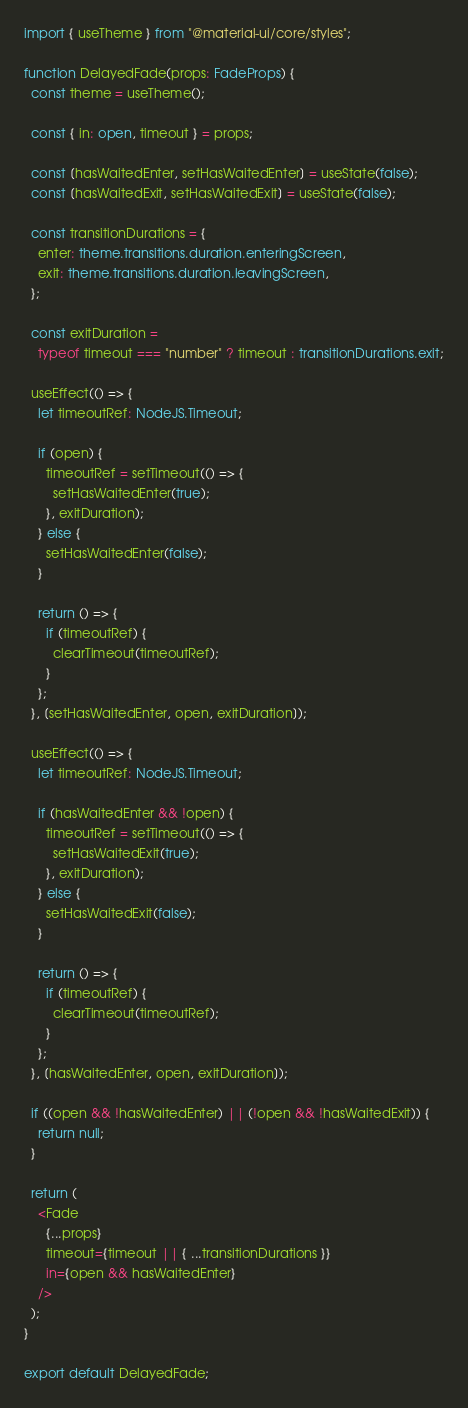Convert code to text. <code><loc_0><loc_0><loc_500><loc_500><_TypeScript_>import { useTheme } from "@material-ui/core/styles";

function DelayedFade(props: FadeProps) {
  const theme = useTheme();

  const { in: open, timeout } = props;

  const [hasWaitedEnter, setHasWaitedEnter] = useState(false);
  const [hasWaitedExit, setHasWaitedExit] = useState(false);

  const transitionDurations = {
    enter: theme.transitions.duration.enteringScreen,
    exit: theme.transitions.duration.leavingScreen,
  };

  const exitDuration =
    typeof timeout === "number" ? timeout : transitionDurations.exit;

  useEffect(() => {
    let timeoutRef: NodeJS.Timeout;

    if (open) {
      timeoutRef = setTimeout(() => {
        setHasWaitedEnter(true);
      }, exitDuration);
    } else {
      setHasWaitedEnter(false);
    }

    return () => {
      if (timeoutRef) {
        clearTimeout(timeoutRef);
      }
    };
  }, [setHasWaitedEnter, open, exitDuration]);

  useEffect(() => {
    let timeoutRef: NodeJS.Timeout;

    if (hasWaitedEnter && !open) {
      timeoutRef = setTimeout(() => {
        setHasWaitedExit(true);
      }, exitDuration);
    } else {
      setHasWaitedExit(false);
    }

    return () => {
      if (timeoutRef) {
        clearTimeout(timeoutRef);
      }
    };
  }, [hasWaitedEnter, open, exitDuration]);

  if ((open && !hasWaitedEnter) || (!open && !hasWaitedExit)) {
    return null;
  }

  return (
    <Fade
      {...props}
      timeout={timeout || { ...transitionDurations }}
      in={open && hasWaitedEnter}
    />
  );
}

export default DelayedFade;
</code> 